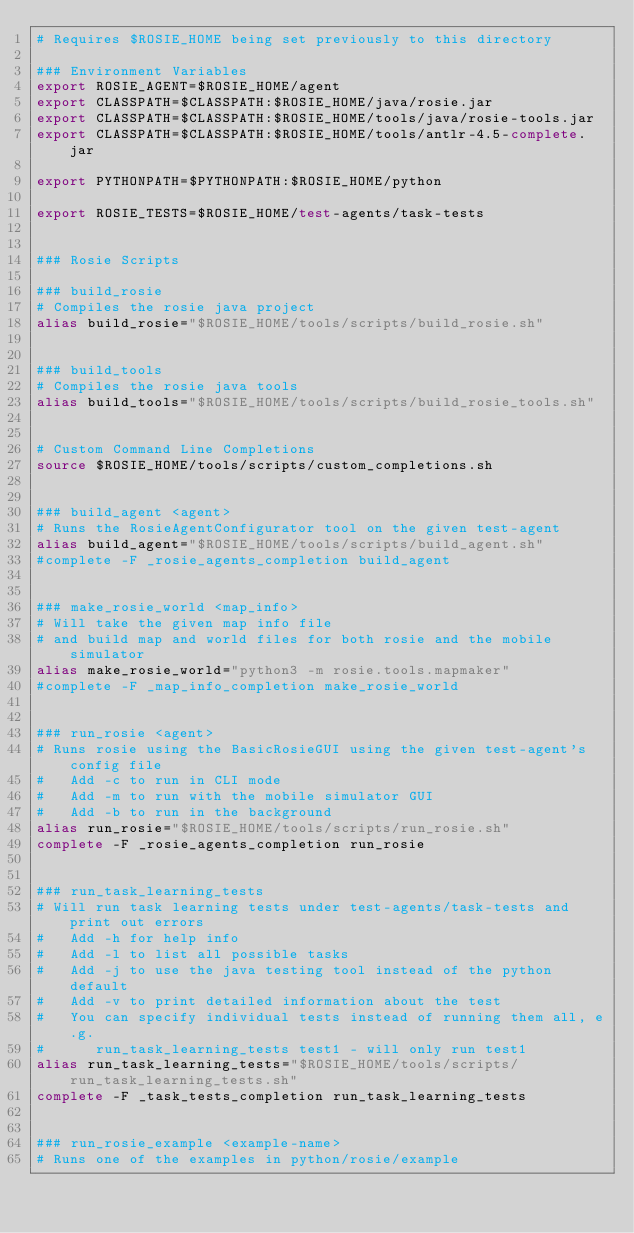<code> <loc_0><loc_0><loc_500><loc_500><_Bash_># Requires $ROSIE_HOME being set previously to this directory

### Environment Variables
export ROSIE_AGENT=$ROSIE_HOME/agent
export CLASSPATH=$CLASSPATH:$ROSIE_HOME/java/rosie.jar
export CLASSPATH=$CLASSPATH:$ROSIE_HOME/tools/java/rosie-tools.jar
export CLASSPATH=$CLASSPATH:$ROSIE_HOME/tools/antlr-4.5-complete.jar

export PYTHONPATH=$PYTHONPATH:$ROSIE_HOME/python

export ROSIE_TESTS=$ROSIE_HOME/test-agents/task-tests


### Rosie Scripts

### build_rosie
# Compiles the rosie java project
alias build_rosie="$ROSIE_HOME/tools/scripts/build_rosie.sh"


### build_tools 
# Compiles the rosie java tools
alias build_tools="$ROSIE_HOME/tools/scripts/build_rosie_tools.sh"


# Custom Command Line Completions
source $ROSIE_HOME/tools/scripts/custom_completions.sh


### build_agent <agent>
# Runs the RosieAgentConfigurator tool on the given test-agent
alias build_agent="$ROSIE_HOME/tools/scripts/build_agent.sh"
#complete -F _rosie_agents_completion build_agent


### make_rosie_world <map_info>
# Will take the given map info file
# and build map and world files for both rosie and the mobile simulator
alias make_rosie_world="python3 -m rosie.tools.mapmaker"
#complete -F _map_info_completion make_rosie_world


### run_rosie <agent>
# Runs rosie using the BasicRosieGUI using the given test-agent's config file
#   Add -c to run in CLI mode
#   Add -m to run with the mobile simulator GUI
#   Add -b to run in the background
alias run_rosie="$ROSIE_HOME/tools/scripts/run_rosie.sh"
complete -F _rosie_agents_completion run_rosie


### run_task_learning_tests
# Will run task learning tests under test-agents/task-tests and print out errors
#   Add -h for help info
#   Add -l to list all possible tasks
#   Add -j to use the java testing tool instead of the python default
#   Add -v to print detailed information about the test
#   You can specify individual tests instead of running them all, e.g.
#      run_task_learning_tests test1 - will only run test1
alias run_task_learning_tests="$ROSIE_HOME/tools/scripts/run_task_learning_tests.sh"
complete -F _task_tests_completion run_task_learning_tests


### run_rosie_example <example-name>
# Runs one of the examples in python/rosie/example</code> 